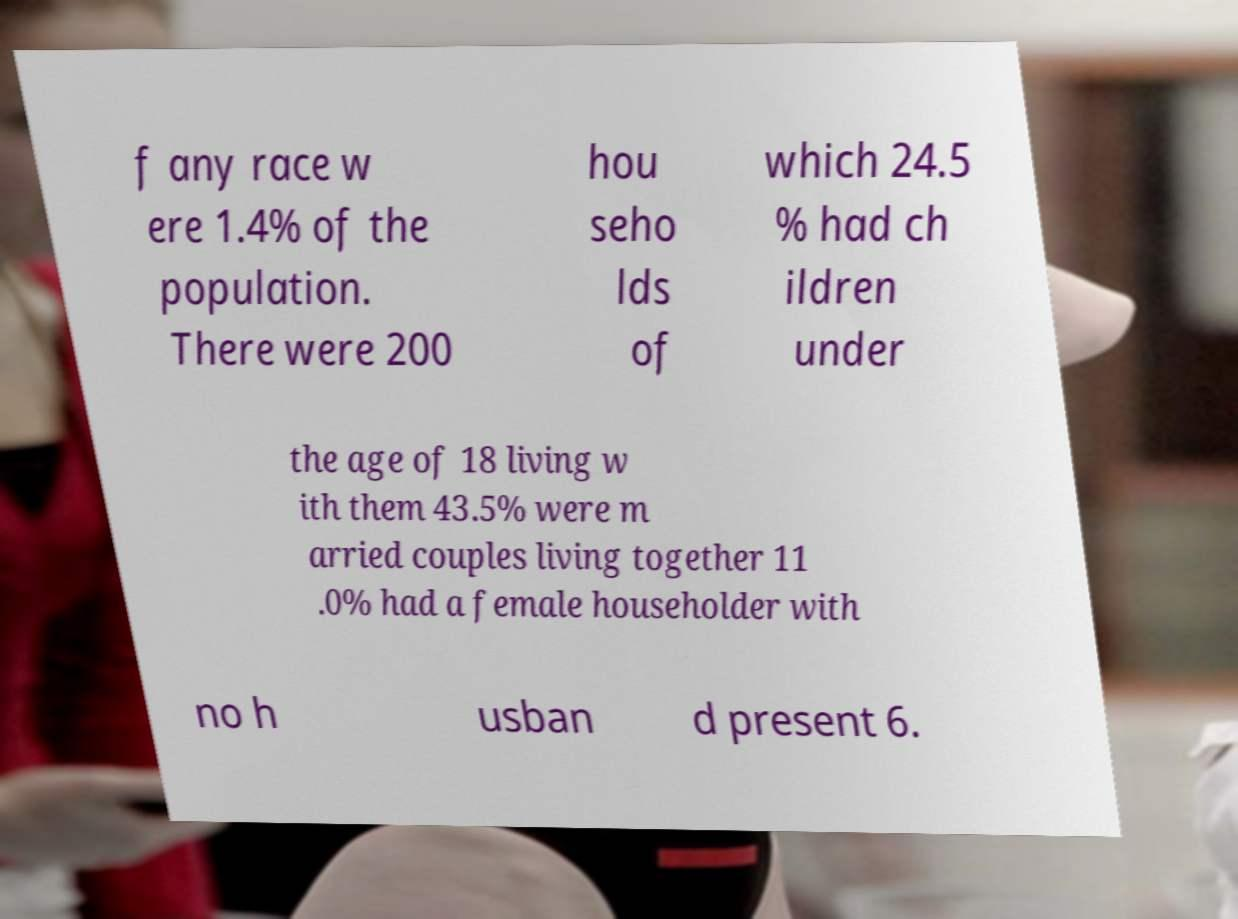Can you accurately transcribe the text from the provided image for me? f any race w ere 1.4% of the population. There were 200 hou seho lds of which 24.5 % had ch ildren under the age of 18 living w ith them 43.5% were m arried couples living together 11 .0% had a female householder with no h usban d present 6. 